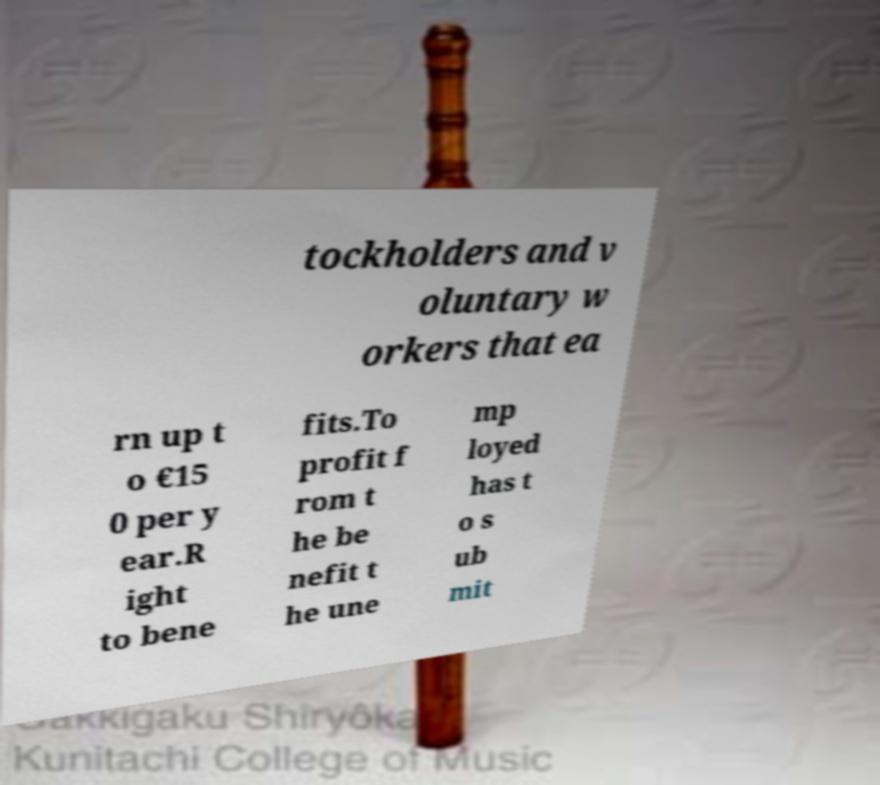There's text embedded in this image that I need extracted. Can you transcribe it verbatim? tockholders and v oluntary w orkers that ea rn up t o €15 0 per y ear.R ight to bene fits.To profit f rom t he be nefit t he une mp loyed has t o s ub mit 